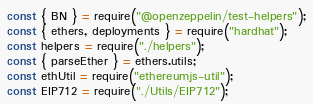Convert code to text. <code><loc_0><loc_0><loc_500><loc_500><_JavaScript_>
const { BN } = require("@openzeppelin/test-helpers");
const { ethers, deployments } = require("hardhat");
const helpers = require("./helpers");
const { parseEther } = ethers.utils;
const ethUtil = require("ethereumjs-util");
const EIP712 = require("./Utils/EIP712");</code> 